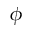Convert formula to latex. <formula><loc_0><loc_0><loc_500><loc_500>\phi</formula> 